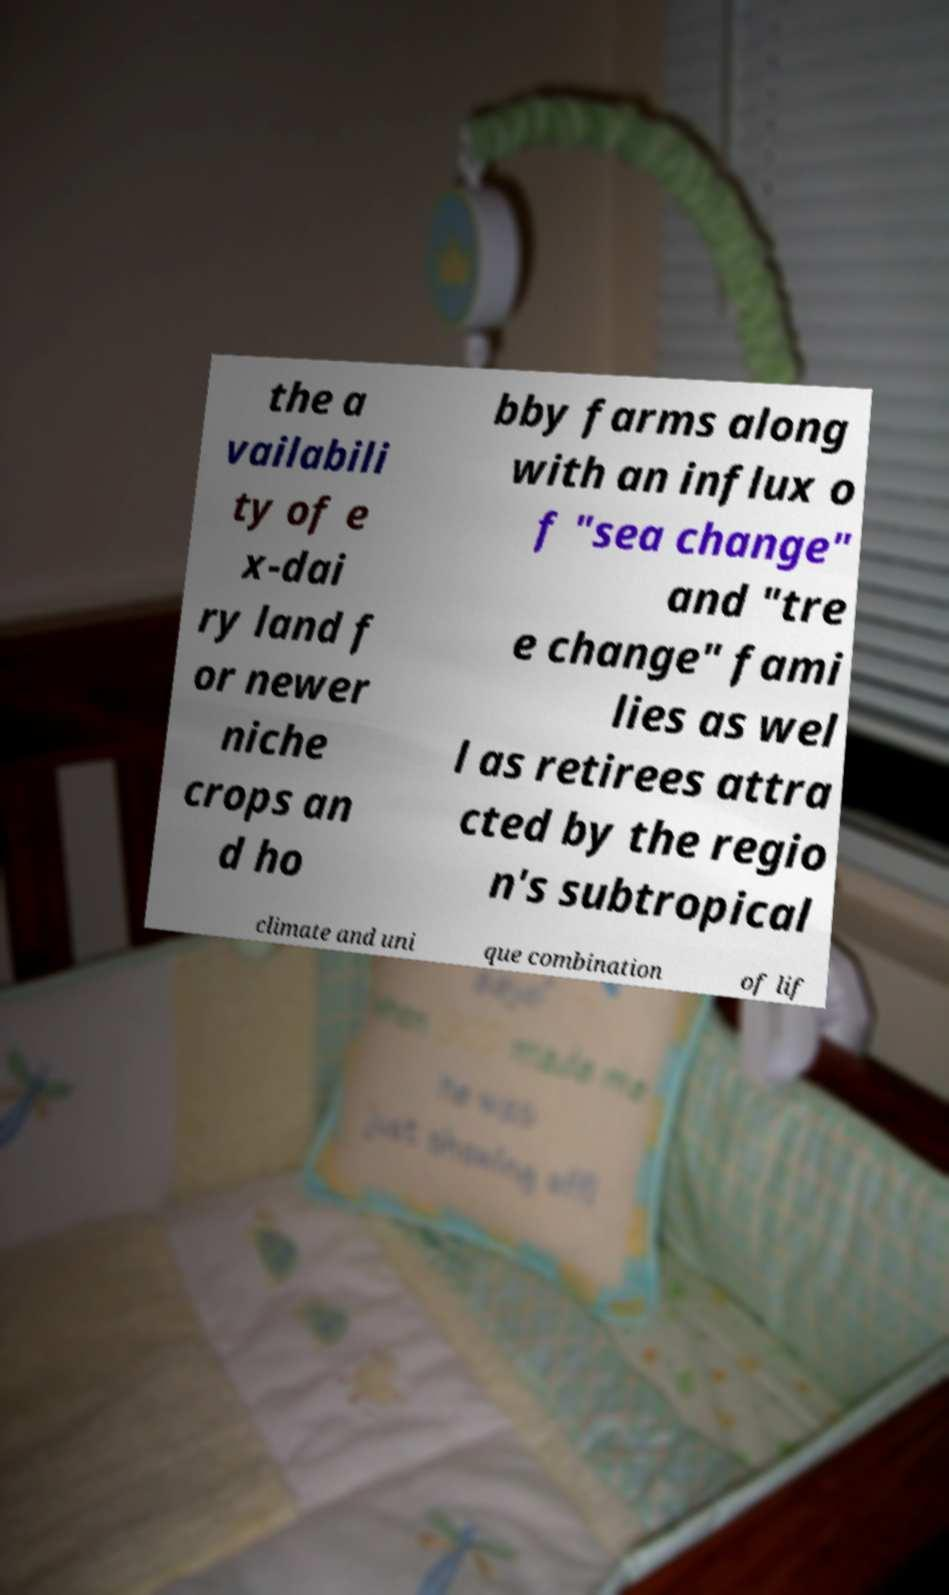For documentation purposes, I need the text within this image transcribed. Could you provide that? the a vailabili ty of e x-dai ry land f or newer niche crops an d ho bby farms along with an influx o f "sea change" and "tre e change" fami lies as wel l as retirees attra cted by the regio n's subtropical climate and uni que combination of lif 